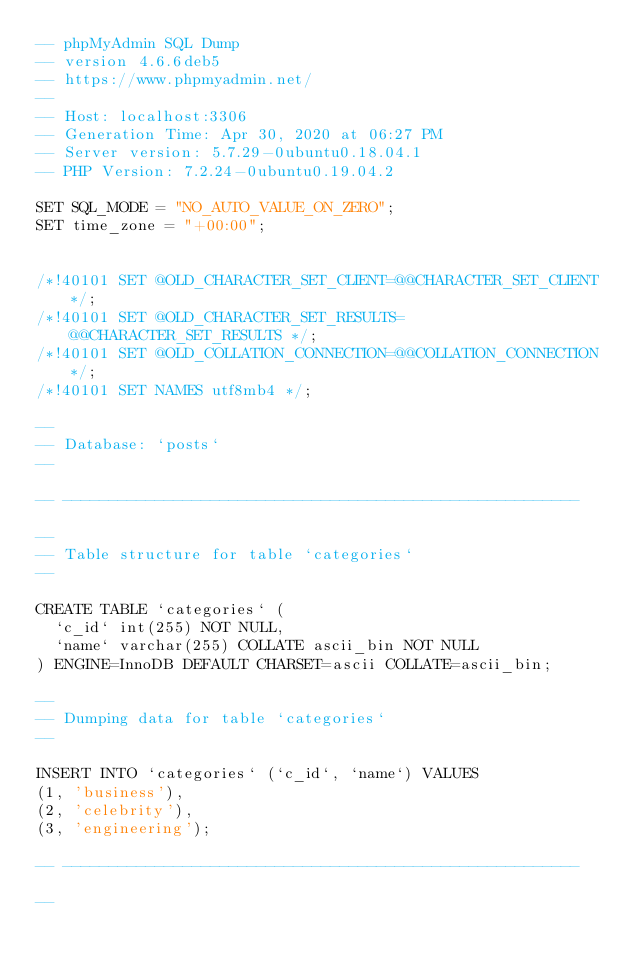Convert code to text. <code><loc_0><loc_0><loc_500><loc_500><_SQL_>-- phpMyAdmin SQL Dump
-- version 4.6.6deb5
-- https://www.phpmyadmin.net/
--
-- Host: localhost:3306
-- Generation Time: Apr 30, 2020 at 06:27 PM
-- Server version: 5.7.29-0ubuntu0.18.04.1
-- PHP Version: 7.2.24-0ubuntu0.19.04.2

SET SQL_MODE = "NO_AUTO_VALUE_ON_ZERO";
SET time_zone = "+00:00";


/*!40101 SET @OLD_CHARACTER_SET_CLIENT=@@CHARACTER_SET_CLIENT */;
/*!40101 SET @OLD_CHARACTER_SET_RESULTS=@@CHARACTER_SET_RESULTS */;
/*!40101 SET @OLD_COLLATION_CONNECTION=@@COLLATION_CONNECTION */;
/*!40101 SET NAMES utf8mb4 */;

--
-- Database: `posts`
--

-- --------------------------------------------------------

--
-- Table structure for table `categories`
--

CREATE TABLE `categories` (
  `c_id` int(255) NOT NULL,
  `name` varchar(255) COLLATE ascii_bin NOT NULL
) ENGINE=InnoDB DEFAULT CHARSET=ascii COLLATE=ascii_bin;

--
-- Dumping data for table `categories`
--

INSERT INTO `categories` (`c_id`, `name`) VALUES
(1, 'business'),
(2, 'celebrity'),
(3, 'engineering');

-- --------------------------------------------------------

--</code> 